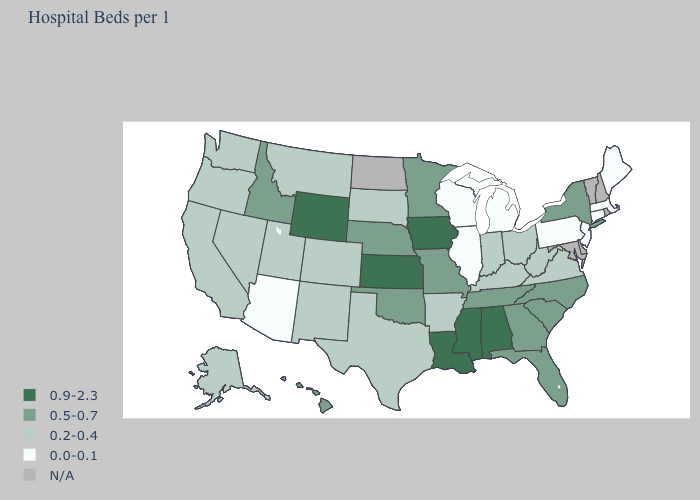Does the map have missing data?
Give a very brief answer. Yes. Does Connecticut have the lowest value in the Northeast?
Quick response, please. Yes. What is the value of Idaho?
Concise answer only. 0.5-0.7. What is the lowest value in states that border Connecticut?
Quick response, please. 0.0-0.1. What is the value of Idaho?
Quick response, please. 0.5-0.7. Does the first symbol in the legend represent the smallest category?
Answer briefly. No. Which states hav the highest value in the South?
Quick response, please. Alabama, Louisiana, Mississippi. What is the highest value in the South ?
Answer briefly. 0.9-2.3. Does Arizona have the lowest value in the USA?
Write a very short answer. Yes. Name the states that have a value in the range 0.5-0.7?
Short answer required. Florida, Georgia, Hawaii, Idaho, Minnesota, Missouri, Nebraska, New York, North Carolina, Oklahoma, South Carolina, Tennessee. Among the states that border Oregon , which have the lowest value?
Concise answer only. California, Nevada, Washington. Name the states that have a value in the range N/A?
Keep it brief. Delaware, Maryland, New Hampshire, North Dakota, Rhode Island, Vermont. Which states have the lowest value in the South?
Keep it brief. Arkansas, Kentucky, Texas, Virginia, West Virginia. Name the states that have a value in the range N/A?
Give a very brief answer. Delaware, Maryland, New Hampshire, North Dakota, Rhode Island, Vermont. 